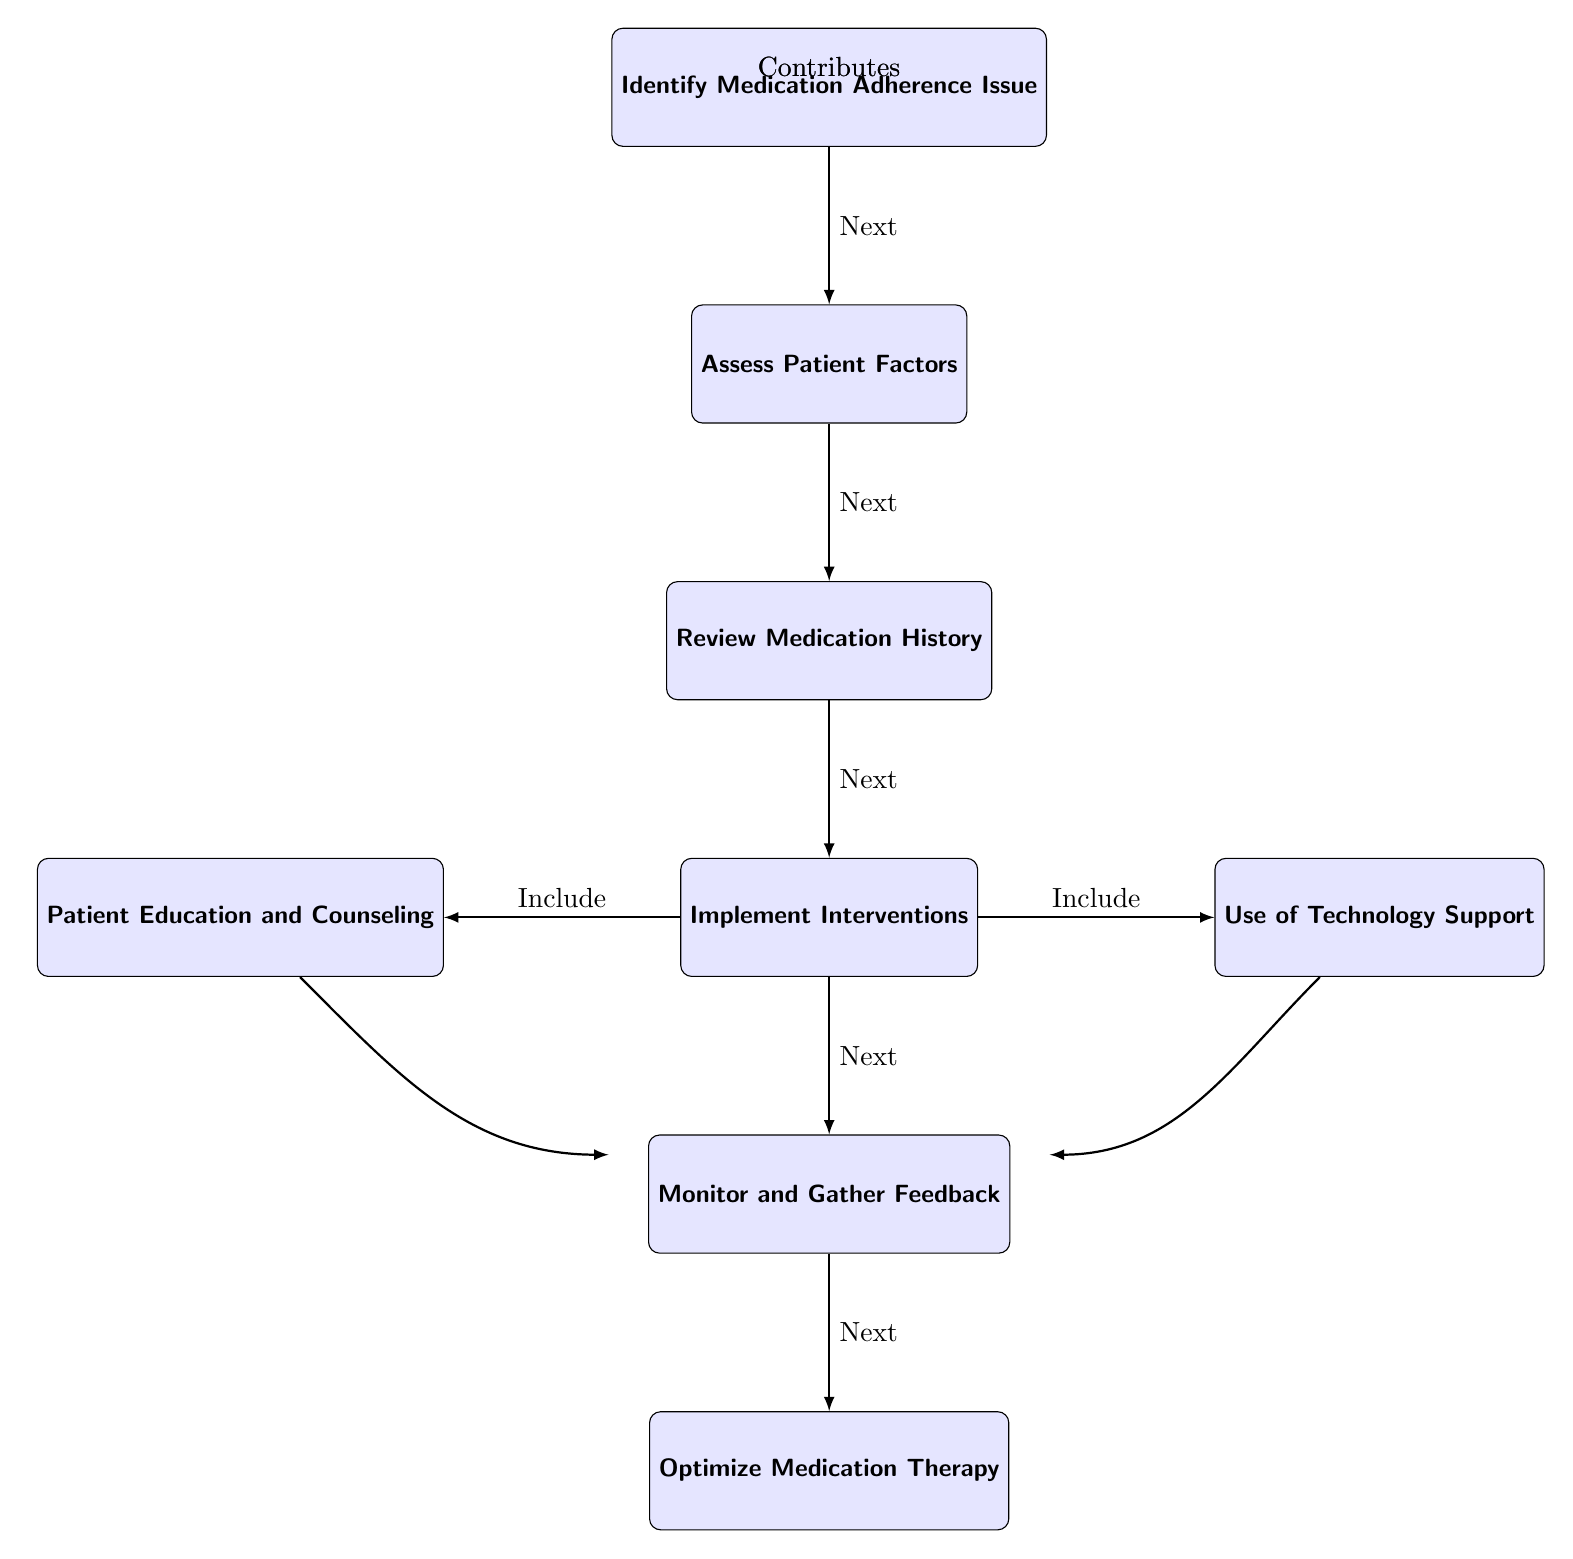What is the first step in the medication adherence flowchart? The diagram shows that the first step is labeled "Identify Medication Adherence Issue." This is the topmost node in the flowchart, indicating the starting point of the process.
Answer: Identify Medication Adherence Issue How many main nodes are present in the medication adherence flowchart? By counting each distinctive box in the diagram, there are a total of 6 main nodes: "Identify Medication Adherence Issue," "Assess Patient Factors," "Review Medication History," "Implement Interventions," "Monitor and Gather Feedback," and "Optimize Medication Therapy."
Answer: 6 What does the "Implement Interventions" node connect to? The "Implement Interventions" node directly connects to the "Monitor and Gather Feedback" node below it, and it also connects to "Patient Education and Counseling" on the left and "Use of Technology Support" on the right, indicating that these elements are included in the interventions.
Answer: Monitor and Gather Feedback, Patient Education and Counseling, Use of Technology Support What is the last step after monitoring and gathering feedback? According to the flowchart, the last step that follows "Monitor and Gather Feedback" is "Optimize Medication Therapy," which indicates that this is the final step in the process to refine medication therapy based on feedback.
Answer: Optimize Medication Therapy Which nodes contribute to the "Monitor and Gather Feedback" step? The diagram indicates that both "Patient Education and Counseling" and "Use of Technology Support" contribute to the "Monitor and Gather Feedback" step, showing that these elements play a role in the feedback process.
Answer: Patient Education and Counseling, Use of Technology Support What type of lines are used to connect the nodes in this flowchart? The connections between the nodes in the diagram are indicated with arrows, which show the direction of the flow from one step to the next. The use of arrows signifies that the steps follow a certain order.
Answer: Arrows What is the purpose of the "Assess Patient Factors" step in the flowchart? The "Assess Patient Factors" step is designed to understand the specific factors affecting the patient, providing necessary information before moving on to the review of the medication history. This is essential for tailoring interventions appropriately.
Answer: Understand patient factors What is the relationship between "Patient Education and Counseling" and "Implement Interventions"? The "Patient Education and Counseling" node is connected to the "Implement Interventions" node, indicating that educational efforts must be included in the overall interventions implemented in response to adherence issues.
Answer: Include in interventions 